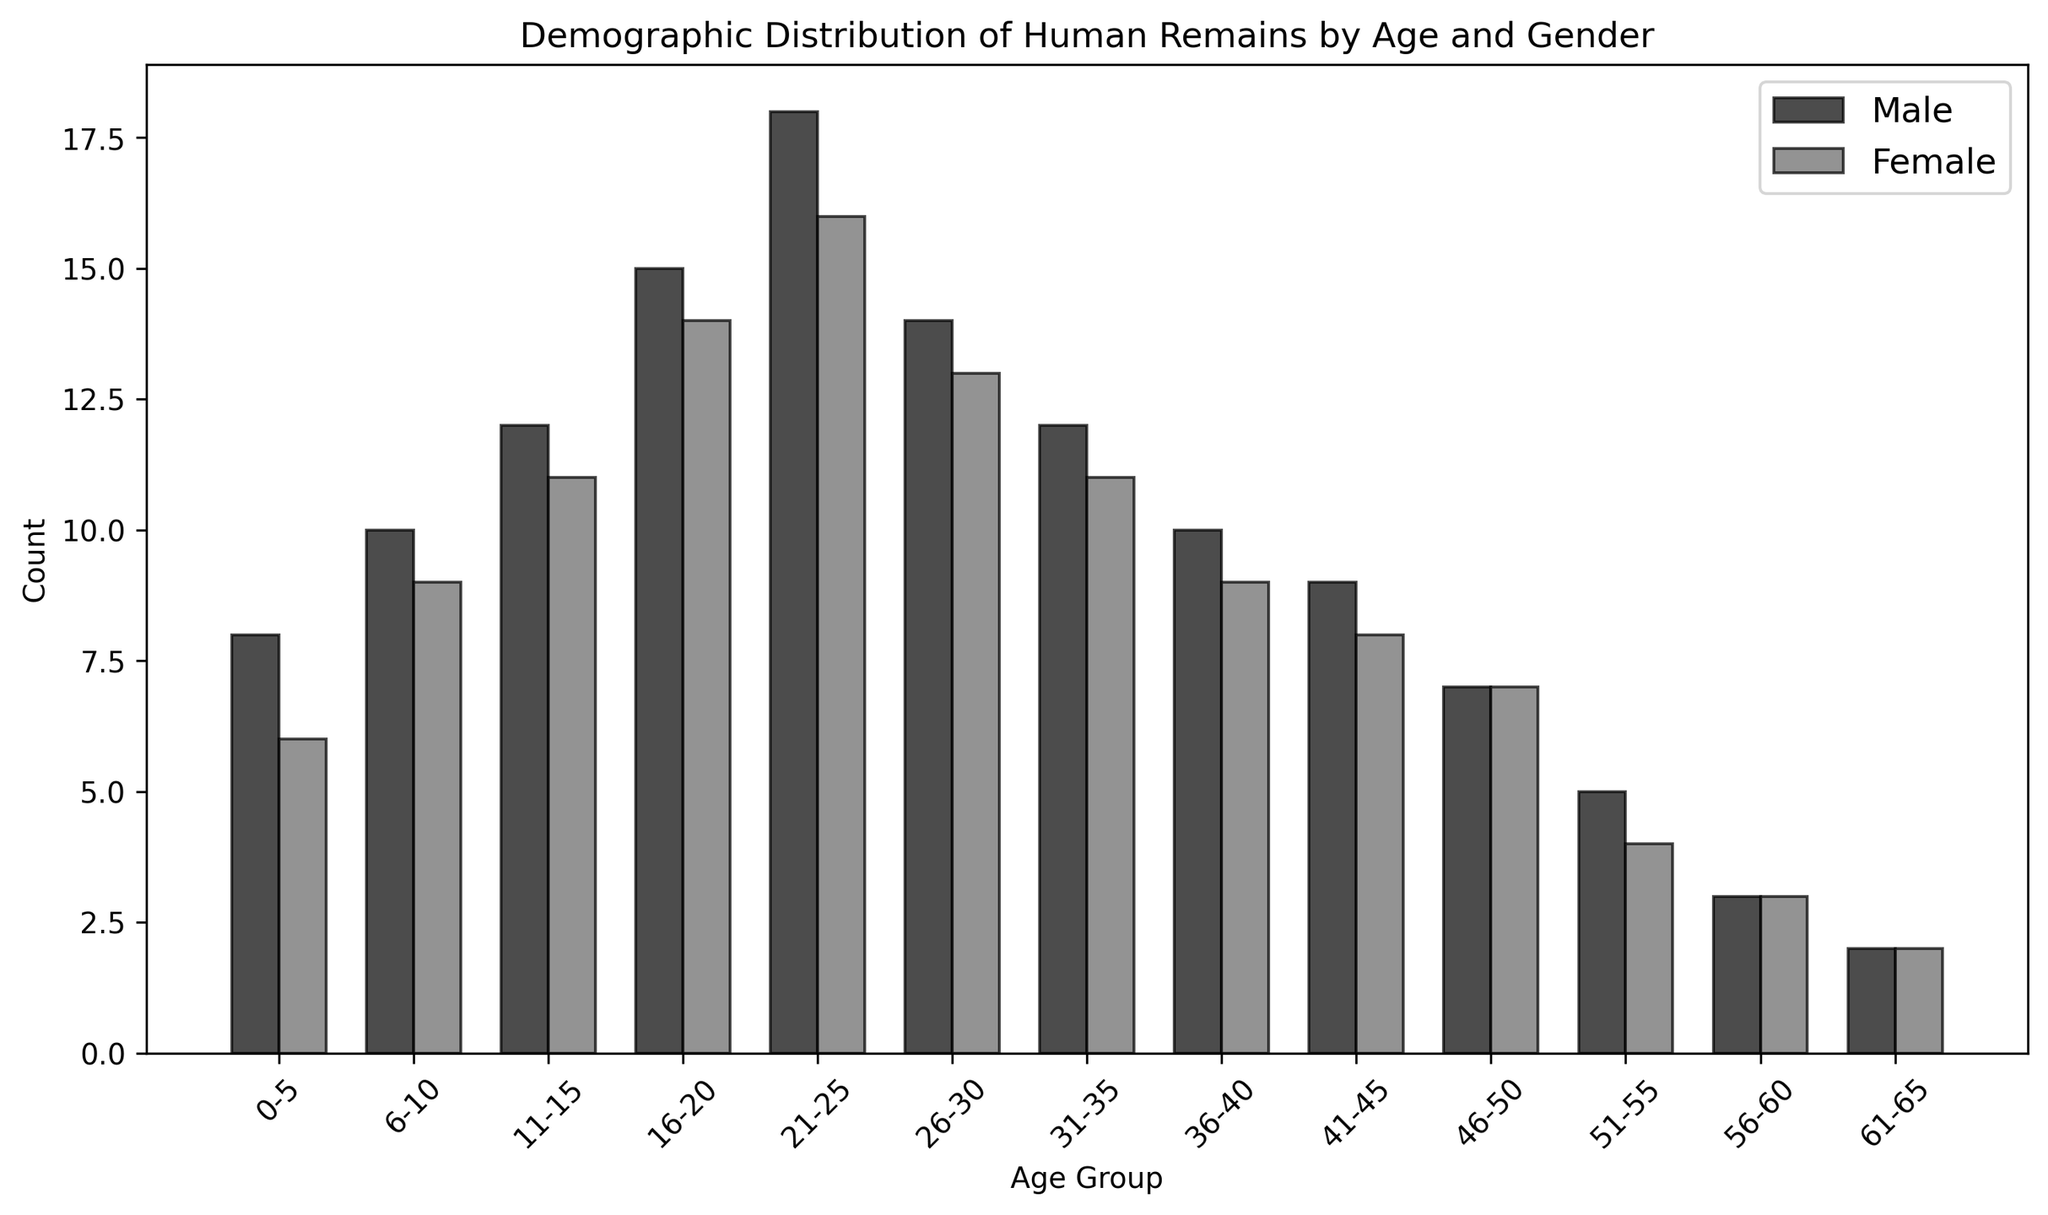Which age group has the highest male count? Scan the male bar heights for each age group. The age group 21-25 has the highest bar for males.
Answer: 21-25 What is the total count of human remains in the 16-20 age group? Add the counts of males and females in the 16-20 age group (15 + 14).
Answer: 29 Are there more male or female human remains in the 31-35 age group? Compare the bar heights of males and females in the 31-35 age group. Males have a count of 12 and females have a count of 11.
Answer: Male Which gender has the smaller count in the 56-60 age group? Compare the bar heights of males and females in the 56-60 age group. Both have an equal count of 3.
Answer: Equal What is the difference between the male and female counts in the 0-5 age group? Subtract the female count from the male count in the 0-5 age group (8 - 6).
Answer: 2 How many more remains are there for males than females in the 21-25 age group? Subtract the female count from the male count in the 21-25 age group (18 - 16).
Answer: 2 What is the average count of human remains for females across all age groups? Sum up the female counts (6 + 9 + 11 + 14 + 16 + 13 + 11 + 9 + 8 + 7 + 4 + 3 + 2 = 113). Divide by the number of age groups (113 / 13).
Answer: 8.692 Which age group has the lowest overall count of human remains? Check the total counts for all age groups and find the one with the lowest sum. The 61-65 age group has the lowest total (2 + 2 = 4).
Answer: 61-65 In which age groups do males have a higher count than females? Compare the male and female bar heights for each age group. Males have higher counts in 0-5, 6-10, 11-15, 16-20, 21-25, 26-30, 31-35, 36-40.
Answer: 0-5, 6-10, 11-15, 16-20, 21-25, 26-30, 31-35, 36-40 What's the combined count of human remains for the age groups under 20 years old? Add the counts for both genders in the age groups 0-5, 6-10, 11-15, and 16-20 (14 + 19 + 23 + 29).
Answer: 85 